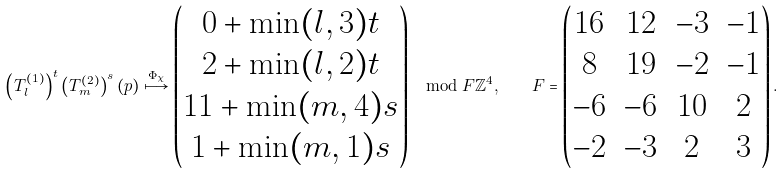Convert formula to latex. <formula><loc_0><loc_0><loc_500><loc_500>\left ( T ^ { ( 1 ) } _ { l } \right ) ^ { t } \left ( T ^ { ( 2 ) } _ { m } \right ) ^ { s } ( p ) \overset { \Phi _ { \chi } } { \longmapsto } \begin{pmatrix} 0 + \min ( l , 3 ) t \\ 2 + \min ( l , 2 ) t \\ 1 1 + \min ( m , 4 ) s \\ 1 + \min ( m , 1 ) s \end{pmatrix} \mod F { \mathbb { Z } } ^ { 4 } , \quad F = \begin{pmatrix} 1 6 & 1 2 & - 3 & - 1 \\ 8 & 1 9 & - 2 & - 1 \\ - 6 & - 6 & 1 0 & 2 \\ - 2 & - 3 & 2 & 3 \end{pmatrix} .</formula> 